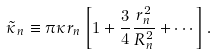Convert formula to latex. <formula><loc_0><loc_0><loc_500><loc_500>\tilde { \kappa } _ { n } \equiv \pi \kappa r _ { n } \left [ 1 + \frac { 3 } { 4 } \frac { r _ { n } ^ { 2 } } { R _ { n } ^ { 2 } } + \cdots \right ] .</formula> 